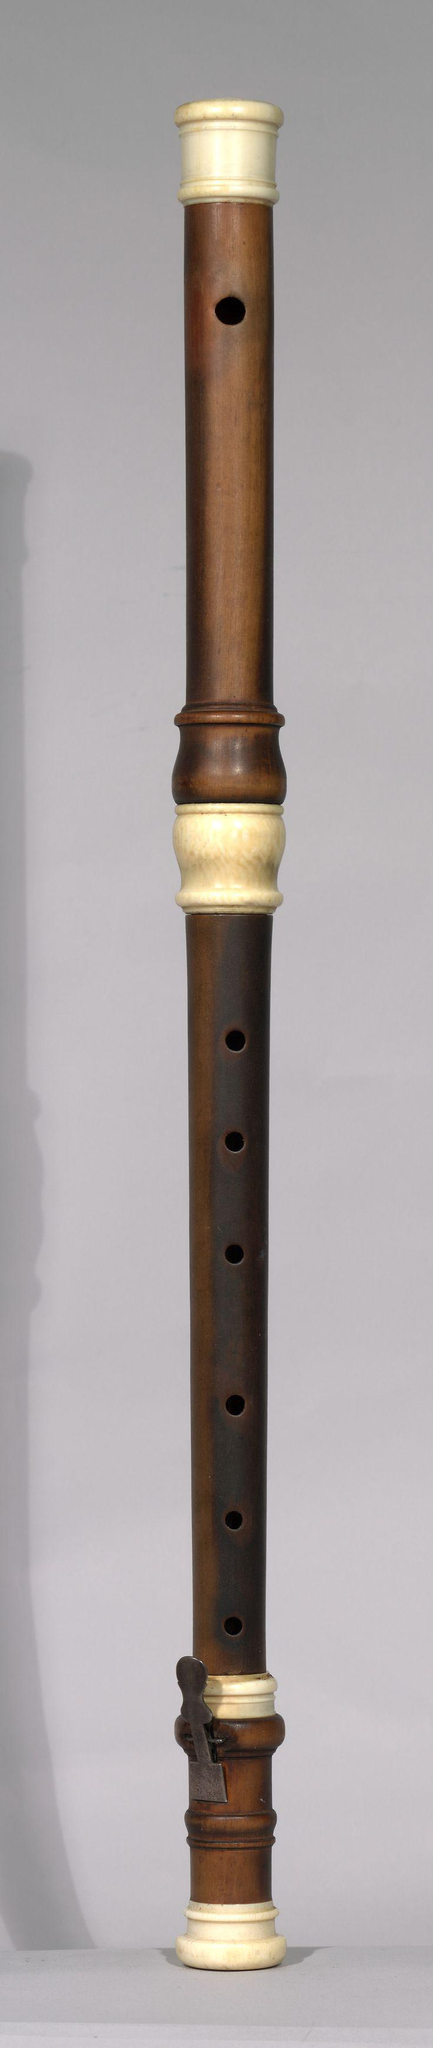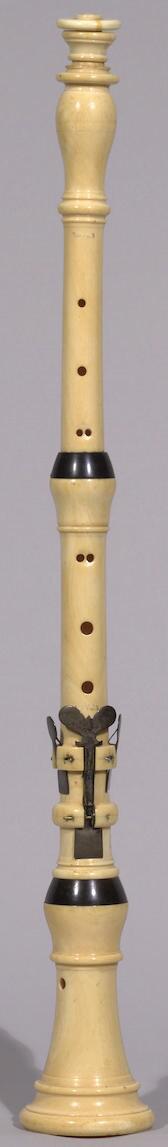The first image is the image on the left, the second image is the image on the right. For the images shown, is this caption "One of the instruments is completely silver colored." true? Answer yes or no. No. The first image is the image on the left, the second image is the image on the right. Considering the images on both sides, is "The instrument on the left is silver and is displayed at an angle, while the instrument on the right is a dark color and is displayed more vertically." valid? Answer yes or no. No. 